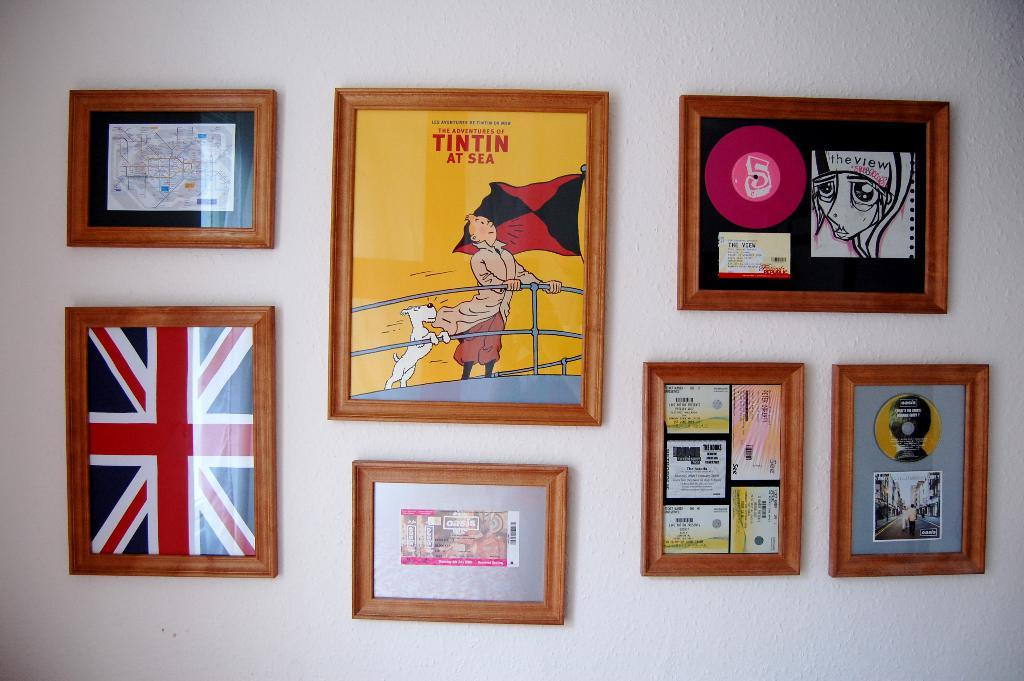What can be seen hanging on the wall in the image? There are frames in the image. What is the color of the wall where the frames are hung? The wall is white. Where is the park located in the image? There is no park present in the image; it only mentions frames on a white wall. 